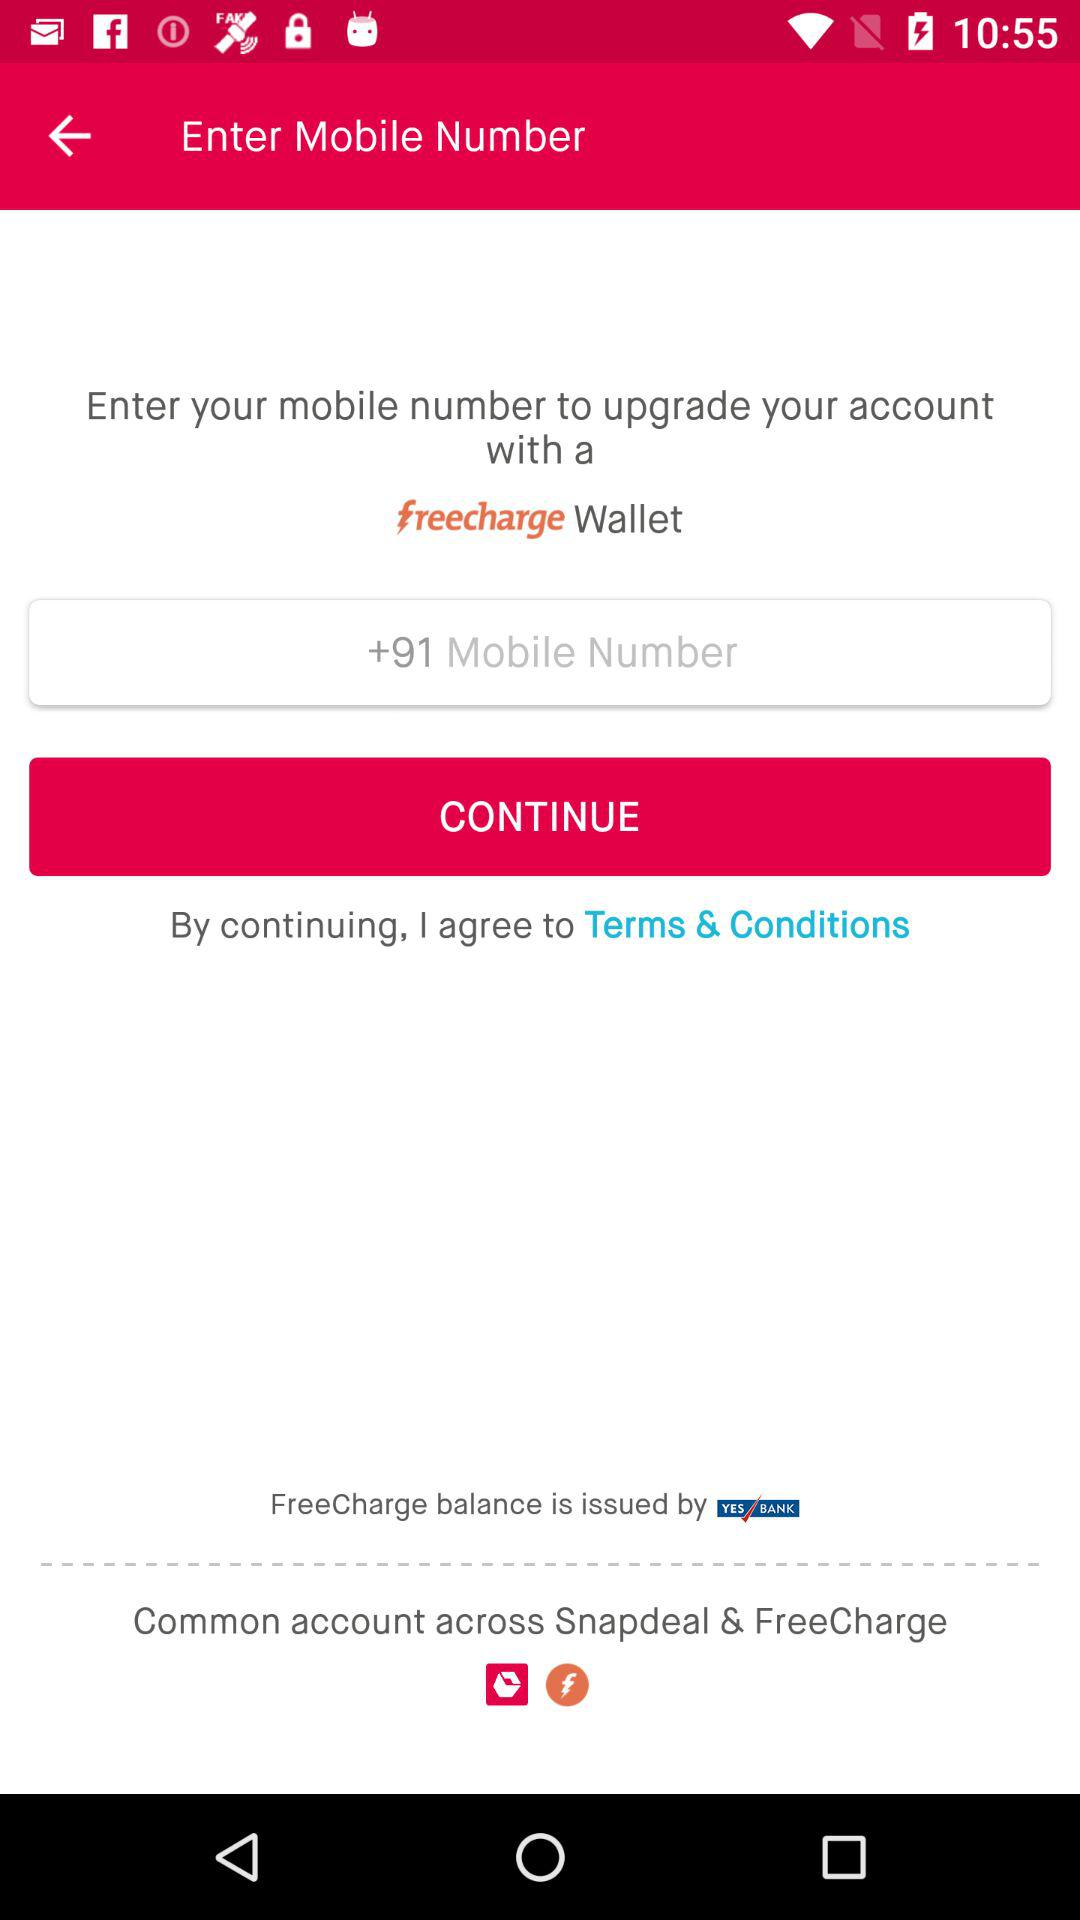What is the requirement to upgrade an account with the "FreeCharge" wallet? The requirement to upgrade an account with the "FreeCharge" wallet is a mobile number. 